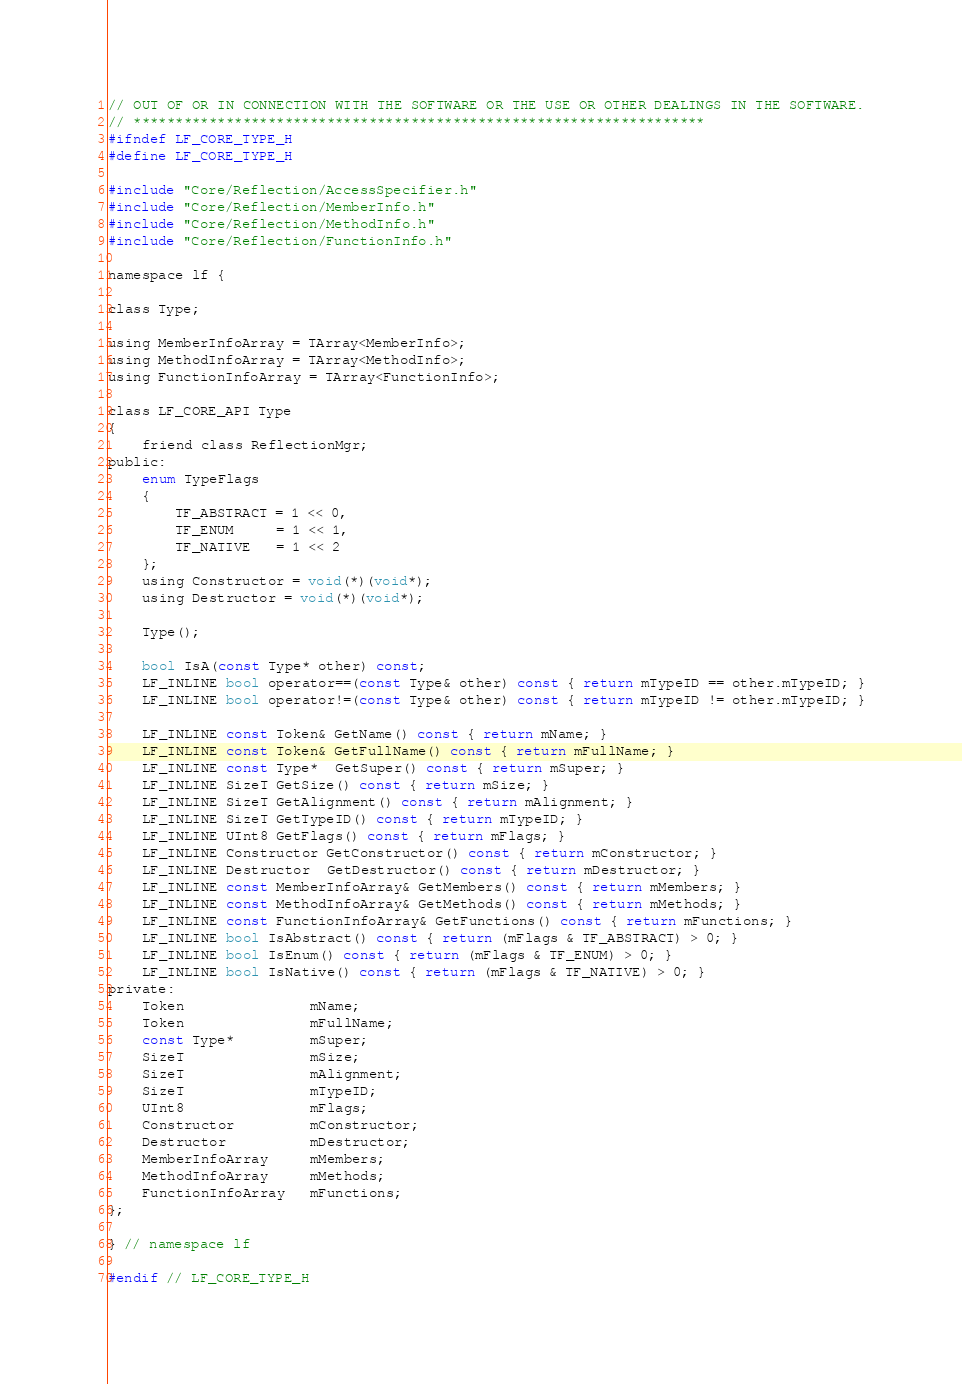Convert code to text. <code><loc_0><loc_0><loc_500><loc_500><_C_>// OUT OF OR IN CONNECTION WITH THE SOFTWARE OR THE USE OR OTHER DEALINGS IN THE SOFTWARE.
// ********************************************************************
#ifndef LF_CORE_TYPE_H
#define LF_CORE_TYPE_H

#include "Core/Reflection/AccessSpecifier.h"
#include "Core/Reflection/MemberInfo.h"
#include "Core/Reflection/MethodInfo.h"
#include "Core/Reflection/FunctionInfo.h"

namespace lf {

class Type;

using MemberInfoArray = TArray<MemberInfo>;
using MethodInfoArray = TArray<MethodInfo>;
using FunctionInfoArray = TArray<FunctionInfo>;

class LF_CORE_API Type
{
    friend class ReflectionMgr;
public:
    enum TypeFlags
    {
        TF_ABSTRACT = 1 << 0,
        TF_ENUM     = 1 << 1,
        TF_NATIVE   = 1 << 2
    };
    using Constructor = void(*)(void*);
    using Destructor = void(*)(void*);

    Type();

    bool IsA(const Type* other) const;
    LF_INLINE bool operator==(const Type& other) const { return mTypeID == other.mTypeID; }
    LF_INLINE bool operator!=(const Type& other) const { return mTypeID != other.mTypeID; }

    LF_INLINE const Token& GetName() const { return mName; }
    LF_INLINE const Token& GetFullName() const { return mFullName; }
    LF_INLINE const Type*  GetSuper() const { return mSuper; }
    LF_INLINE SizeT GetSize() const { return mSize; }
    LF_INLINE SizeT GetAlignment() const { return mAlignment; }
    LF_INLINE SizeT GetTypeID() const { return mTypeID; }
    LF_INLINE UInt8 GetFlags() const { return mFlags; }
    LF_INLINE Constructor GetConstructor() const { return mConstructor; }
    LF_INLINE Destructor  GetDestructor() const { return mDestructor; }
    LF_INLINE const MemberInfoArray& GetMembers() const { return mMembers; }
    LF_INLINE const MethodInfoArray& GetMethods() const { return mMethods; }
    LF_INLINE const FunctionInfoArray& GetFunctions() const { return mFunctions; }
    LF_INLINE bool IsAbstract() const { return (mFlags & TF_ABSTRACT) > 0; }
    LF_INLINE bool IsEnum() const { return (mFlags & TF_ENUM) > 0; }
    LF_INLINE bool IsNative() const { return (mFlags & TF_NATIVE) > 0; }
private:
    Token               mName;
    Token               mFullName;
    const Type*         mSuper;
    SizeT               mSize;
    SizeT               mAlignment;
    SizeT               mTypeID;
    UInt8               mFlags;
    Constructor         mConstructor;
    Destructor          mDestructor;
    MemberInfoArray     mMembers;
    MethodInfoArray     mMethods;
    FunctionInfoArray   mFunctions;
};

} // namespace lf

#endif // LF_CORE_TYPE_H</code> 